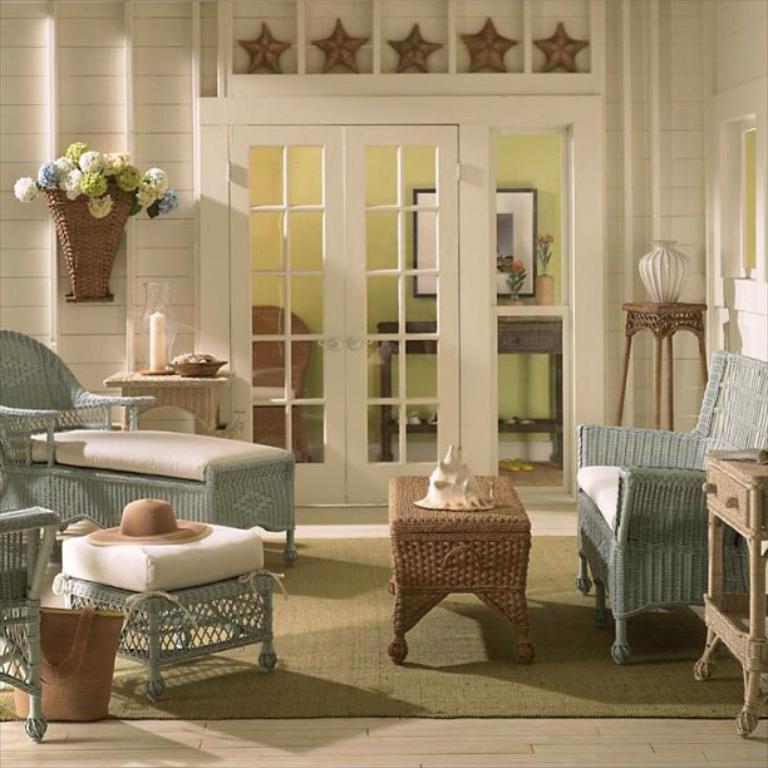In one or two sentences, can you explain what this image depicts? In a room there is flower vase a sofa and a table beside that there is a hat on table and stars on wall above the door. 